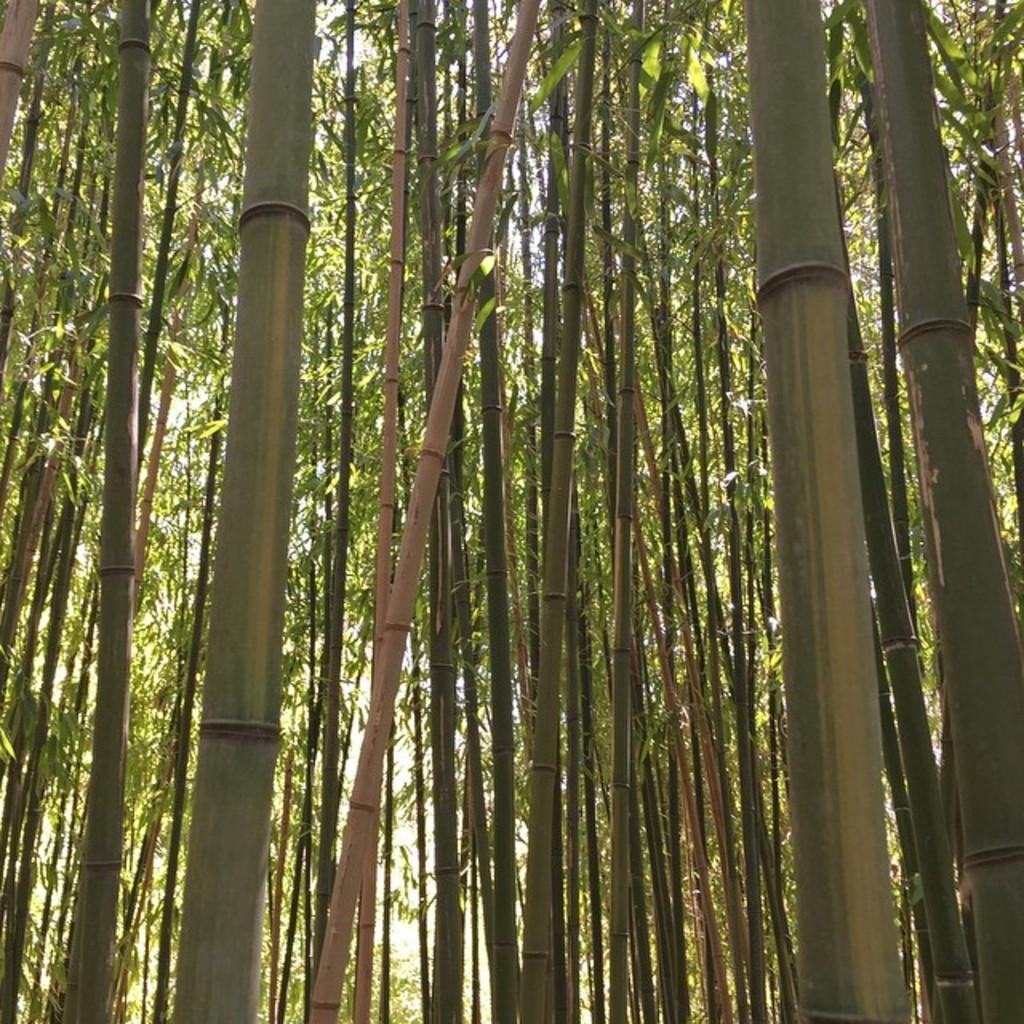What type of vegetation can be seen in the image? There are trees in the image. What part of the natural environment is visible in the image? The sky is visible in the background of the image. What type of veil is draped over the trees in the image? There is no veil present in the image; it only features trees and the sky. 